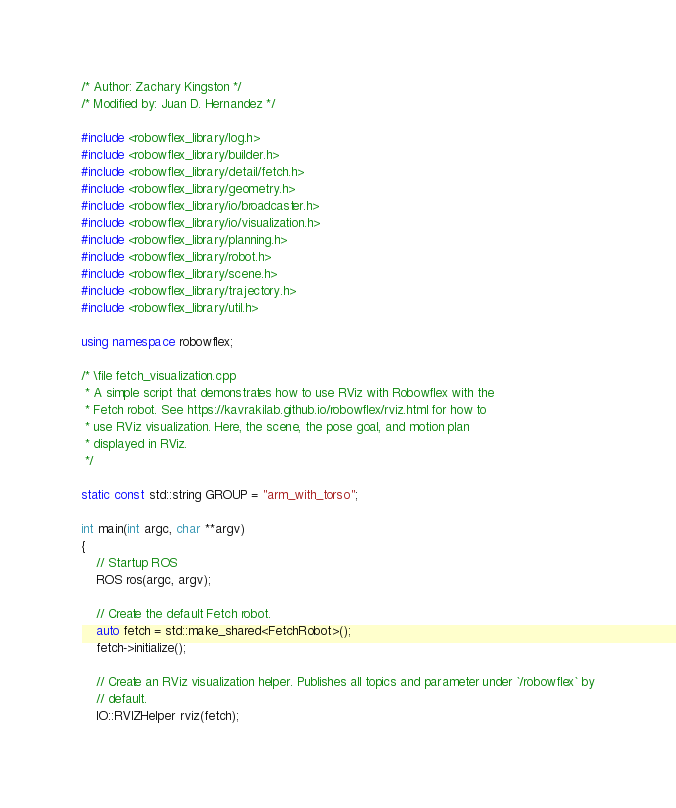<code> <loc_0><loc_0><loc_500><loc_500><_C++_>/* Author: Zachary Kingston */
/* Modified by: Juan D. Hernandez */

#include <robowflex_library/log.h>
#include <robowflex_library/builder.h>
#include <robowflex_library/detail/fetch.h>
#include <robowflex_library/geometry.h>
#include <robowflex_library/io/broadcaster.h>
#include <robowflex_library/io/visualization.h>
#include <robowflex_library/planning.h>
#include <robowflex_library/robot.h>
#include <robowflex_library/scene.h>
#include <robowflex_library/trajectory.h>
#include <robowflex_library/util.h>

using namespace robowflex;

/* \file fetch_visualization.cpp
 * A simple script that demonstrates how to use RViz with Robowflex with the
 * Fetch robot. See https://kavrakilab.github.io/robowflex/rviz.html for how to
 * use RViz visualization. Here, the scene, the pose goal, and motion plan
 * displayed in RViz.
 */

static const std::string GROUP = "arm_with_torso";

int main(int argc, char **argv)
{
    // Startup ROS
    ROS ros(argc, argv);

    // Create the default Fetch robot.
    auto fetch = std::make_shared<FetchRobot>();
    fetch->initialize();

    // Create an RViz visualization helper. Publishes all topics and parameter under `/robowflex` by
    // default.
    IO::RVIZHelper rviz(fetch);</code> 